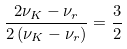<formula> <loc_0><loc_0><loc_500><loc_500>\frac { 2 \nu _ { K } - \nu _ { r } } { 2 \left ( \nu _ { K } - \nu _ { r } \right ) } = \frac { 3 } { 2 }</formula> 